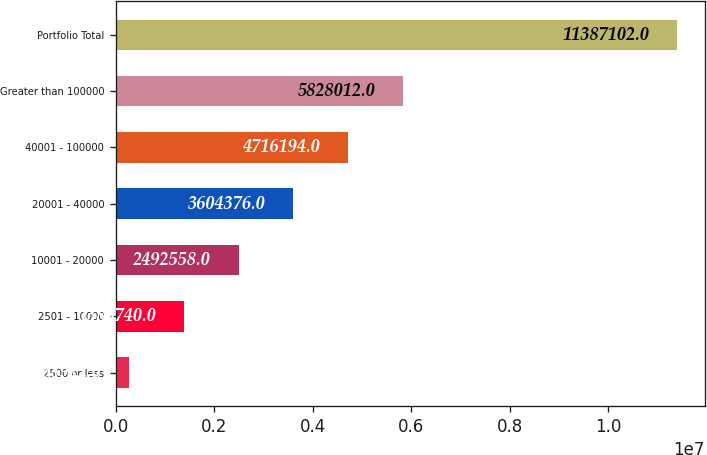<chart> <loc_0><loc_0><loc_500><loc_500><bar_chart><fcel>2500 or less<fcel>2501 - 10000<fcel>10001 - 20000<fcel>20001 - 40000<fcel>40001 - 100000<fcel>Greater than 100000<fcel>Portfolio Total<nl><fcel>268922<fcel>1.38074e+06<fcel>2.49256e+06<fcel>3.60438e+06<fcel>4.71619e+06<fcel>5.82801e+06<fcel>1.13871e+07<nl></chart> 